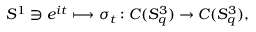<formula> <loc_0><loc_0><loc_500><loc_500>S ^ { 1 } \ni e ^ { i t } \longmapsto \sigma _ { t } \colon C ( S _ { q } ^ { 3 } ) \rightarrow C ( S _ { q } ^ { 3 } ) ,</formula> 